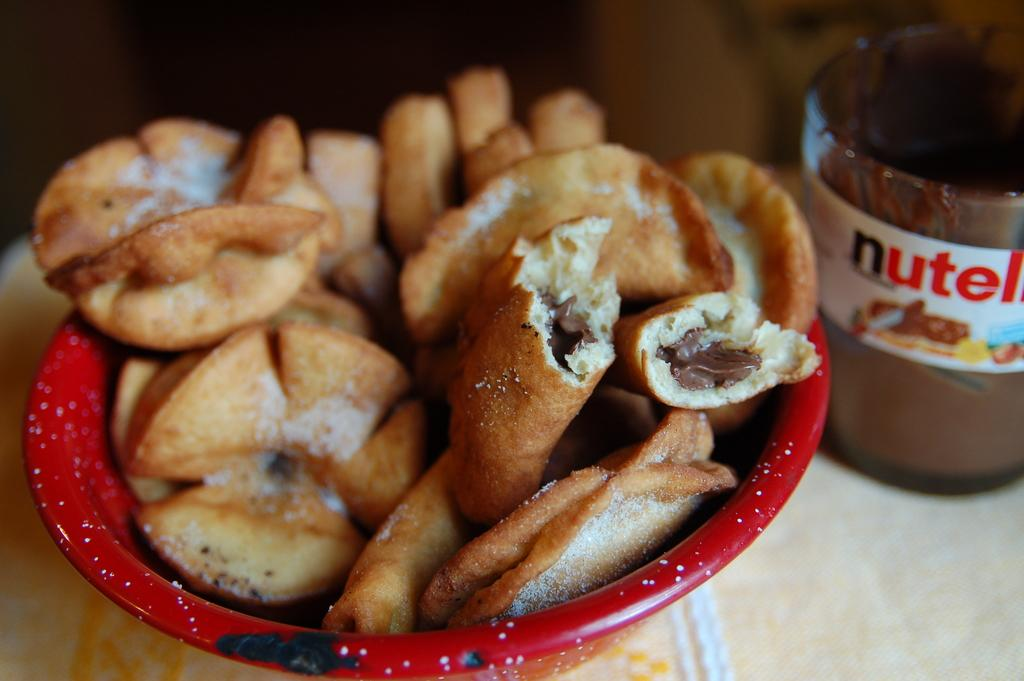What type of food is in the bowl in the image? There are cookies in a bowl in the image. What is in the glass in the image? There is chocolate cream in a glass in the image. What type of cable can be seen connecting the houses in the image? There are no houses or cables present in the image; it only features cookies in a bowl and chocolate cream in a glass. 